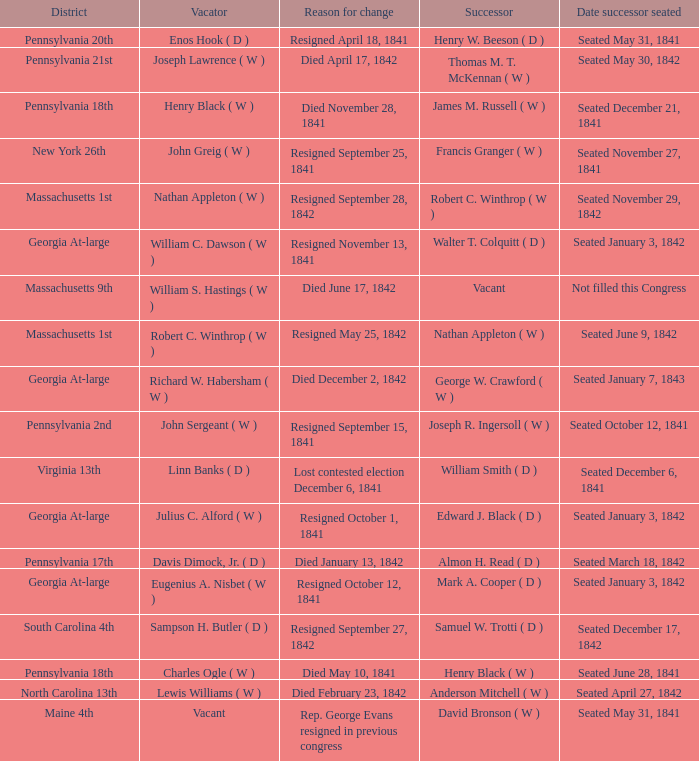Name the successor for north carolina 13th Anderson Mitchell ( W ). 